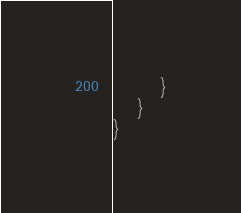<code> <loc_0><loc_0><loc_500><loc_500><_C#_>        }
    }
}</code> 